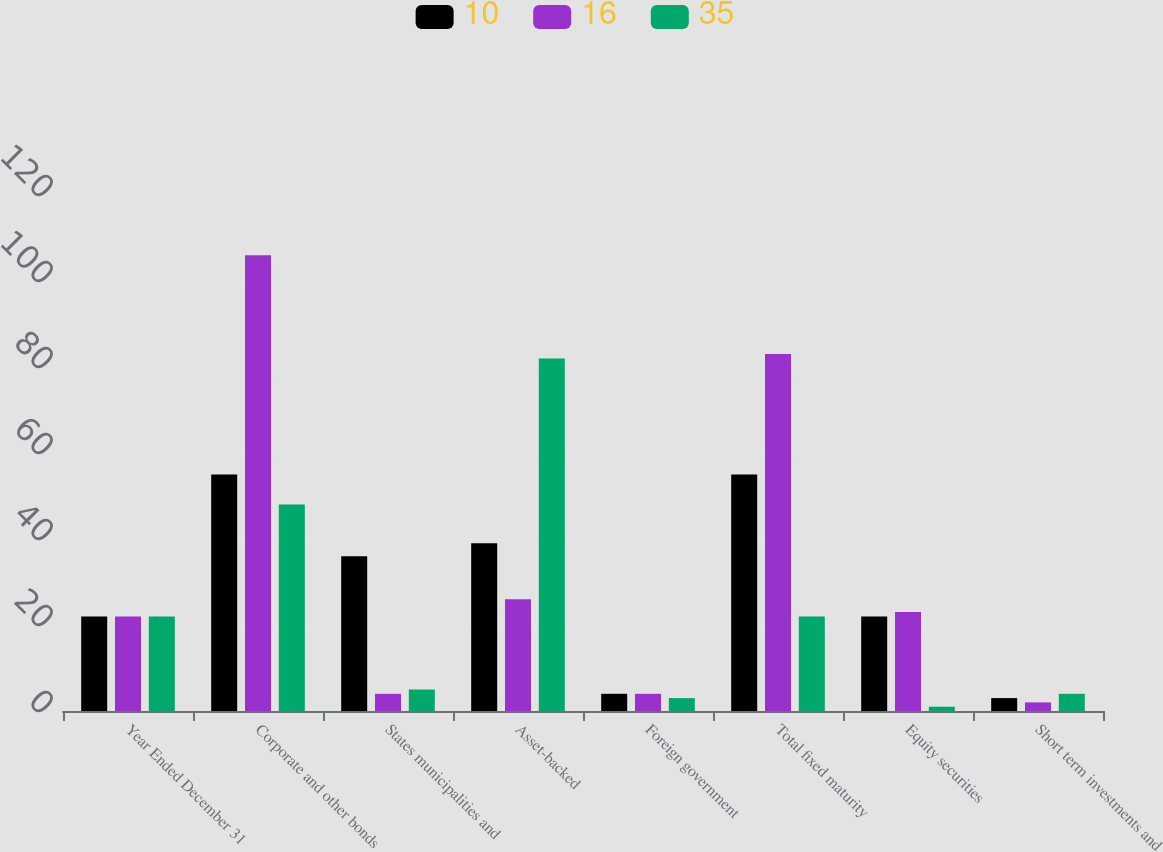Convert chart. <chart><loc_0><loc_0><loc_500><loc_500><stacked_bar_chart><ecel><fcel>Year Ended December 31<fcel>Corporate and other bonds<fcel>States municipalities and<fcel>Asset-backed<fcel>Foreign government<fcel>Total fixed maturity<fcel>Equity securities<fcel>Short term investments and<nl><fcel>10<fcel>22<fcel>55<fcel>36<fcel>39<fcel>4<fcel>55<fcel>22<fcel>3<nl><fcel>16<fcel>22<fcel>106<fcel>4<fcel>26<fcel>4<fcel>83<fcel>23<fcel>2<nl><fcel>35<fcel>22<fcel>48<fcel>5<fcel>82<fcel>3<fcel>22<fcel>1<fcel>4<nl></chart> 